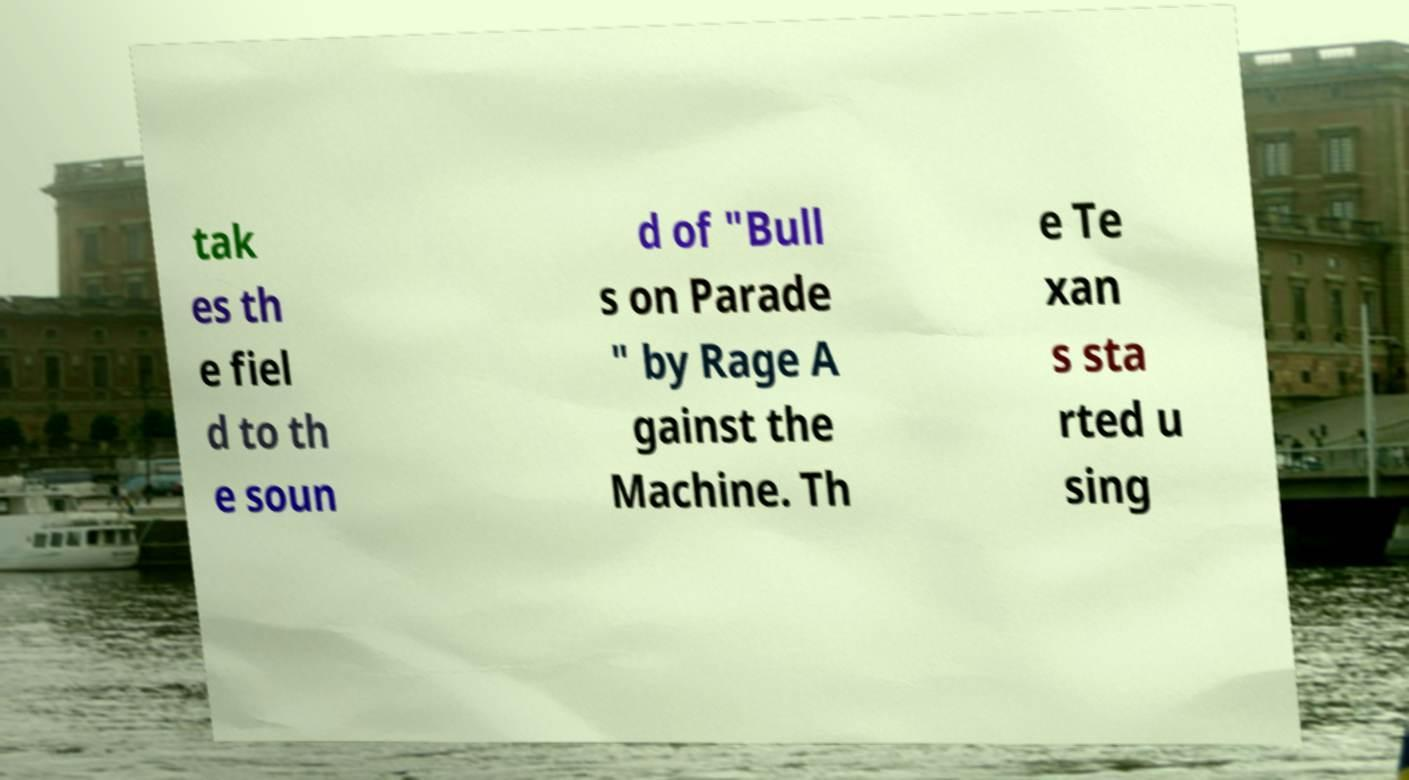Can you accurately transcribe the text from the provided image for me? tak es th e fiel d to th e soun d of "Bull s on Parade " by Rage A gainst the Machine. Th e Te xan s sta rted u sing 